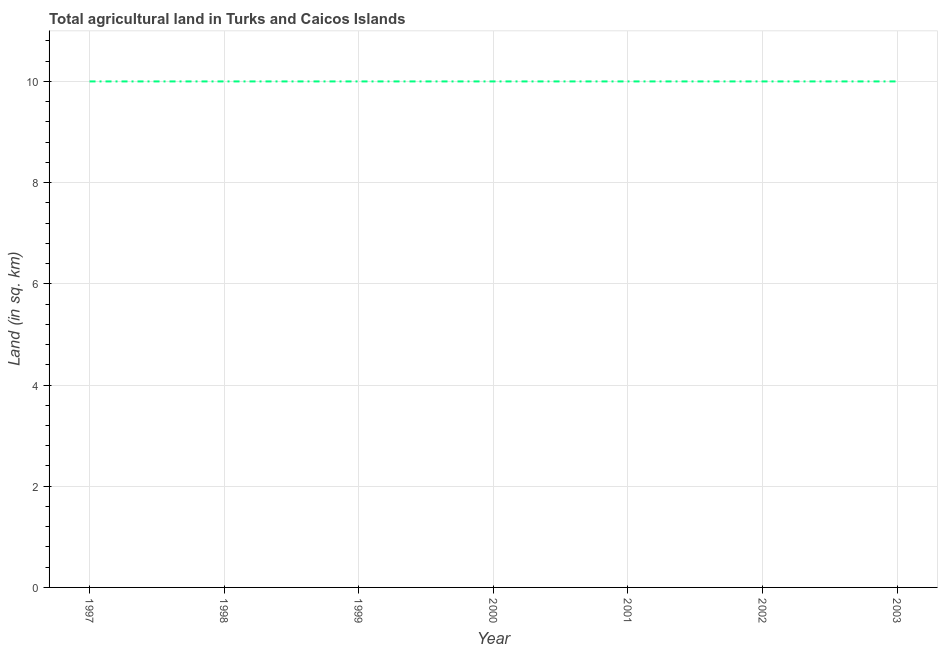What is the agricultural land in 2001?
Provide a succinct answer. 10. Across all years, what is the maximum agricultural land?
Offer a very short reply. 10. Across all years, what is the minimum agricultural land?
Offer a very short reply. 10. What is the sum of the agricultural land?
Your response must be concise. 70. Do a majority of the years between 1998 and 1999 (inclusive) have agricultural land greater than 5.2 sq. km?
Offer a terse response. Yes. What is the ratio of the agricultural land in 2001 to that in 2002?
Your response must be concise. 1. Is the agricultural land in 1997 less than that in 2000?
Ensure brevity in your answer.  No. In how many years, is the agricultural land greater than the average agricultural land taken over all years?
Make the answer very short. 0. What is the difference between two consecutive major ticks on the Y-axis?
Offer a terse response. 2. Does the graph contain any zero values?
Offer a very short reply. No. Does the graph contain grids?
Make the answer very short. Yes. What is the title of the graph?
Your response must be concise. Total agricultural land in Turks and Caicos Islands. What is the label or title of the Y-axis?
Your answer should be very brief. Land (in sq. km). What is the Land (in sq. km) of 1998?
Provide a succinct answer. 10. What is the Land (in sq. km) in 2000?
Give a very brief answer. 10. What is the Land (in sq. km) in 2001?
Ensure brevity in your answer.  10. What is the Land (in sq. km) of 2002?
Provide a short and direct response. 10. What is the difference between the Land (in sq. km) in 1997 and 1999?
Your response must be concise. 0. What is the difference between the Land (in sq. km) in 1997 and 2003?
Your answer should be very brief. 0. What is the difference between the Land (in sq. km) in 1998 and 1999?
Your answer should be very brief. 0. What is the difference between the Land (in sq. km) in 1998 and 2000?
Provide a succinct answer. 0. What is the difference between the Land (in sq. km) in 1998 and 2001?
Your answer should be compact. 0. What is the difference between the Land (in sq. km) in 1999 and 2000?
Your answer should be very brief. 0. What is the difference between the Land (in sq. km) in 1999 and 2002?
Provide a succinct answer. 0. What is the difference between the Land (in sq. km) in 1999 and 2003?
Offer a terse response. 0. What is the difference between the Land (in sq. km) in 2000 and 2001?
Your response must be concise. 0. What is the difference between the Land (in sq. km) in 2000 and 2002?
Your answer should be compact. 0. What is the difference between the Land (in sq. km) in 2001 and 2002?
Your answer should be very brief. 0. What is the difference between the Land (in sq. km) in 2001 and 2003?
Your answer should be very brief. 0. What is the difference between the Land (in sq. km) in 2002 and 2003?
Offer a terse response. 0. What is the ratio of the Land (in sq. km) in 1997 to that in 2001?
Give a very brief answer. 1. What is the ratio of the Land (in sq. km) in 1998 to that in 2000?
Offer a terse response. 1. What is the ratio of the Land (in sq. km) in 1998 to that in 2002?
Your response must be concise. 1. What is the ratio of the Land (in sq. km) in 1999 to that in 2001?
Keep it short and to the point. 1. What is the ratio of the Land (in sq. km) in 2000 to that in 2003?
Make the answer very short. 1. What is the ratio of the Land (in sq. km) in 2001 to that in 2003?
Your answer should be compact. 1. What is the ratio of the Land (in sq. km) in 2002 to that in 2003?
Provide a succinct answer. 1. 